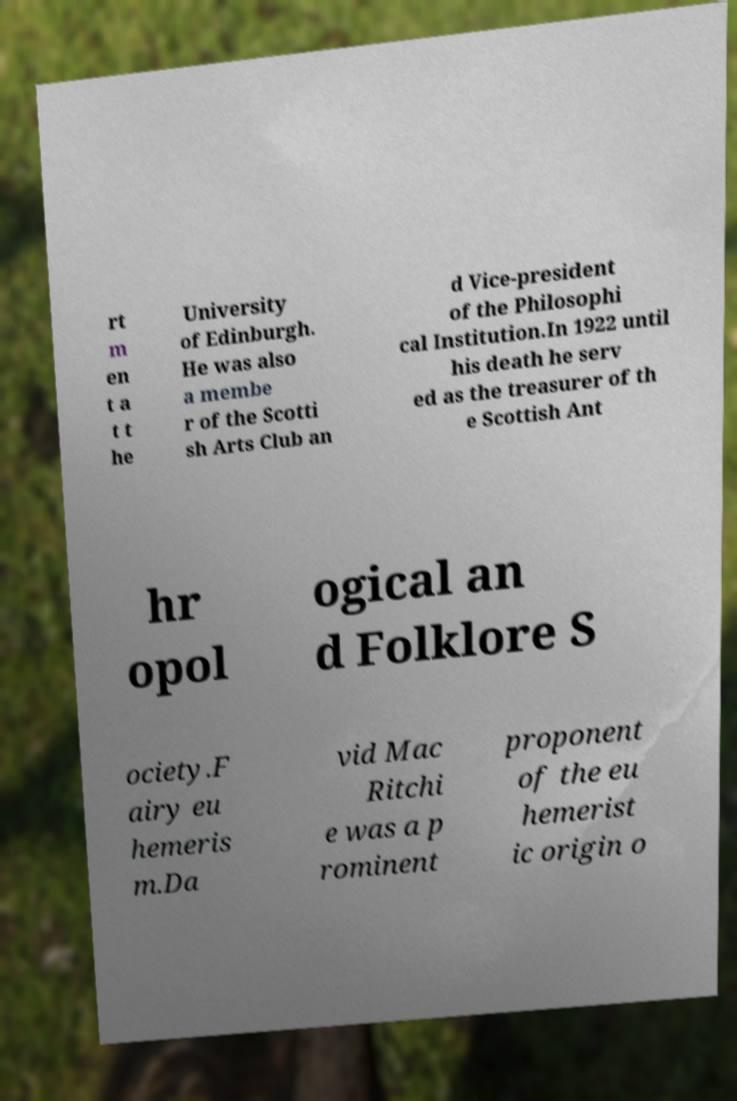Please identify and transcribe the text found in this image. rt m en t a t t he University of Edinburgh. He was also a membe r of the Scotti sh Arts Club an d Vice-president of the Philosophi cal Institution.In 1922 until his death he serv ed as the treasurer of th e Scottish Ant hr opol ogical an d Folklore S ociety.F airy eu hemeris m.Da vid Mac Ritchi e was a p rominent proponent of the eu hemerist ic origin o 